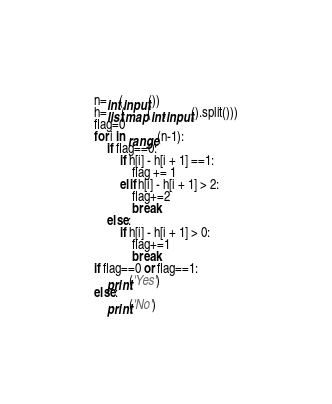<code> <loc_0><loc_0><loc_500><loc_500><_Python_>n=int(input())
h=list(map(int,input().split()))
flag=0
for i in range(n-1):
    if flag==0:
        if h[i] - h[i + 1] ==1:
            flag += 1
        elif h[i] - h[i + 1] > 2:
            flag+=2
            break
    else:
        if h[i] - h[i + 1] > 0:
            flag+=1
            break
if flag==0 or flag==1:
    print('Yes')
else:
    print('No')


</code> 